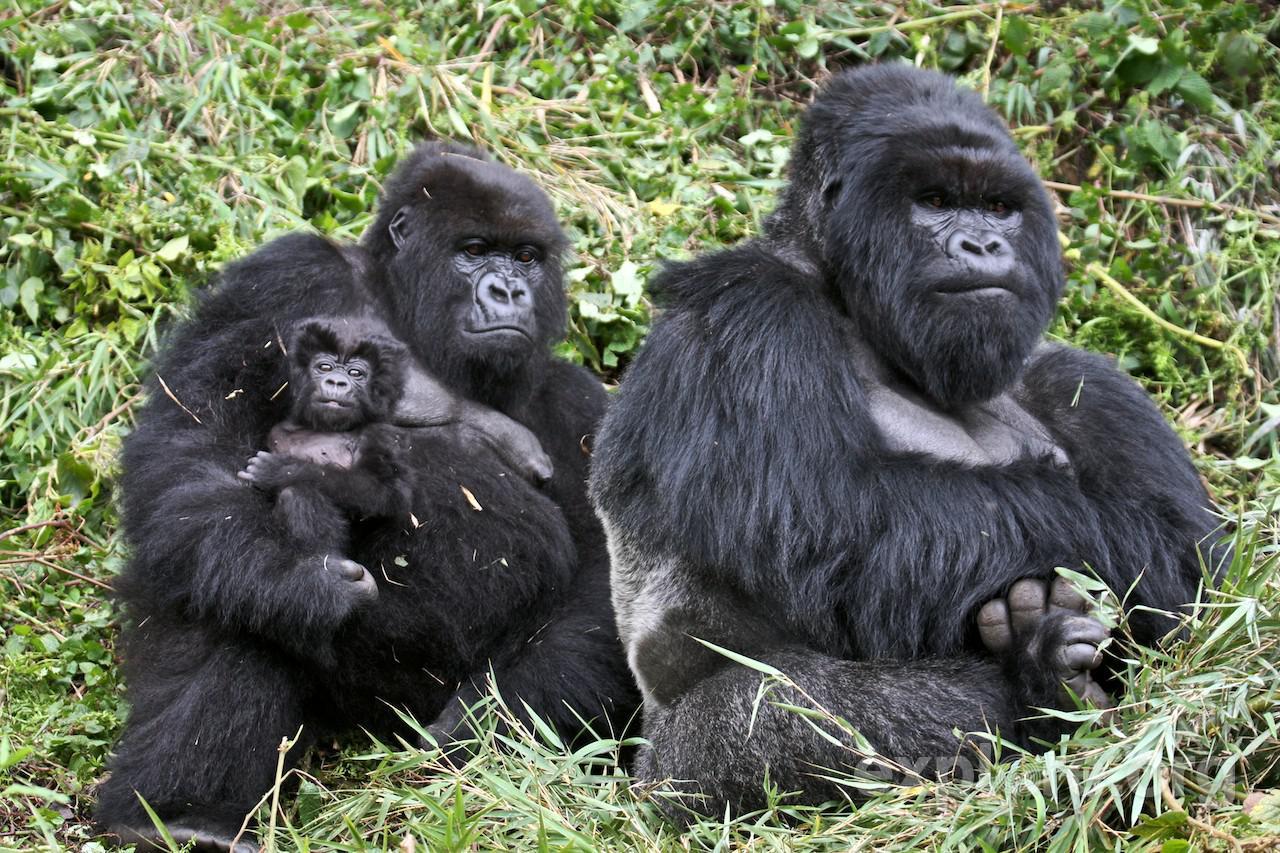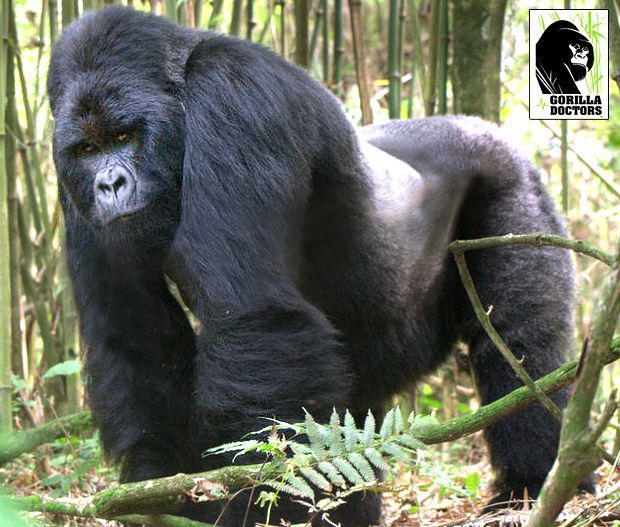The first image is the image on the left, the second image is the image on the right. For the images shown, is this caption "Baby gorilla is visible in the right image." true? Answer yes or no. No. The first image is the image on the left, the second image is the image on the right. Examine the images to the left and right. Is the description "There are two adult gorillas and one baby gorilla in one of the images." accurate? Answer yes or no. Yes. 